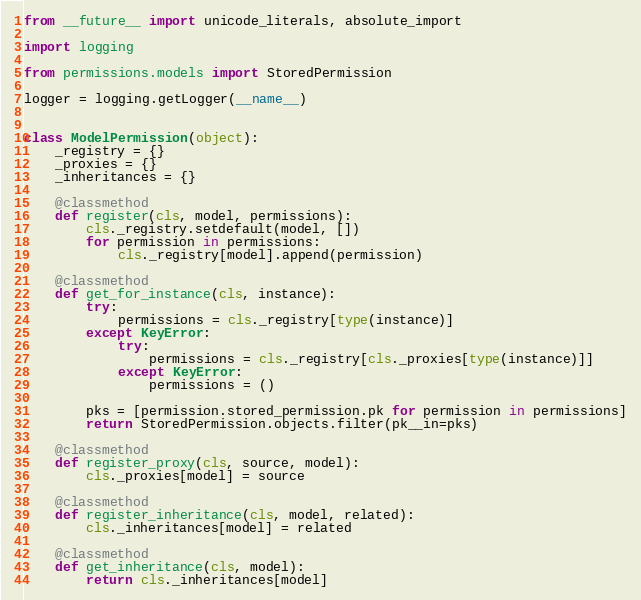Convert code to text. <code><loc_0><loc_0><loc_500><loc_500><_Python_>from __future__ import unicode_literals, absolute_import

import logging

from permissions.models import StoredPermission

logger = logging.getLogger(__name__)


class ModelPermission(object):
    _registry = {}
    _proxies = {}
    _inheritances = {}

    @classmethod
    def register(cls, model, permissions):
        cls._registry.setdefault(model, [])
        for permission in permissions:
            cls._registry[model].append(permission)

    @classmethod
    def get_for_instance(cls, instance):
        try:
            permissions = cls._registry[type(instance)]
        except KeyError:
            try:
                permissions = cls._registry[cls._proxies[type(instance)]]
            except KeyError:
                permissions = ()

        pks = [permission.stored_permission.pk for permission in permissions]
        return StoredPermission.objects.filter(pk__in=pks)

    @classmethod
    def register_proxy(cls, source, model):
        cls._proxies[model] = source

    @classmethod
    def register_inheritance(cls, model, related):
        cls._inheritances[model] = related

    @classmethod
    def get_inheritance(cls, model):
        return cls._inheritances[model]
</code> 